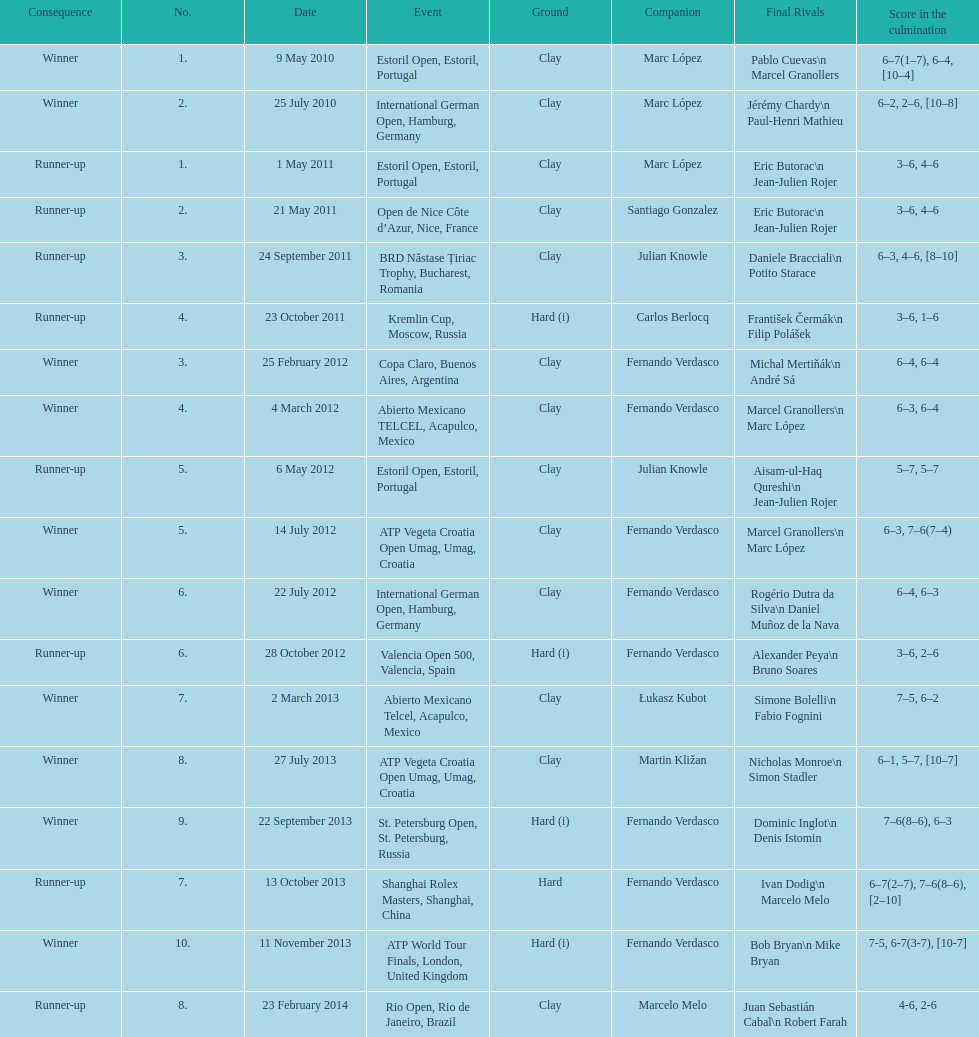Who won both the st.petersburg open and the atp world tour finals? Fernando Verdasco. 